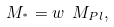Convert formula to latex. <formula><loc_0><loc_0><loc_500><loc_500>M _ { ^ { * } } = w \ M _ { P l } ,</formula> 